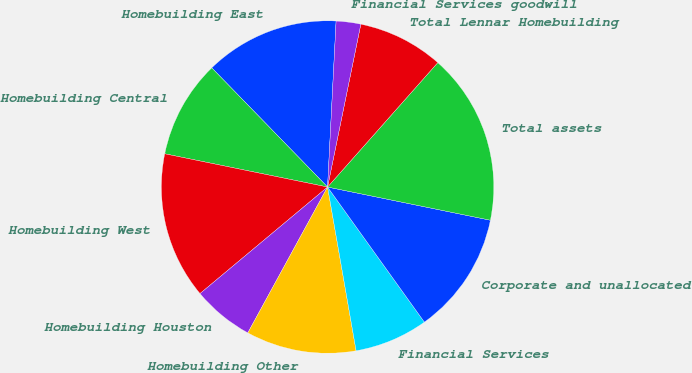Convert chart to OTSL. <chart><loc_0><loc_0><loc_500><loc_500><pie_chart><fcel>Homebuilding East<fcel>Homebuilding Central<fcel>Homebuilding West<fcel>Homebuilding Houston<fcel>Homebuilding Other<fcel>Financial Services<fcel>Corporate and unallocated<fcel>Total assets<fcel>Total Lennar Homebuilding<fcel>Financial Services goodwill<nl><fcel>13.09%<fcel>9.52%<fcel>14.28%<fcel>5.96%<fcel>10.71%<fcel>7.15%<fcel>11.9%<fcel>16.66%<fcel>8.33%<fcel>2.39%<nl></chart> 